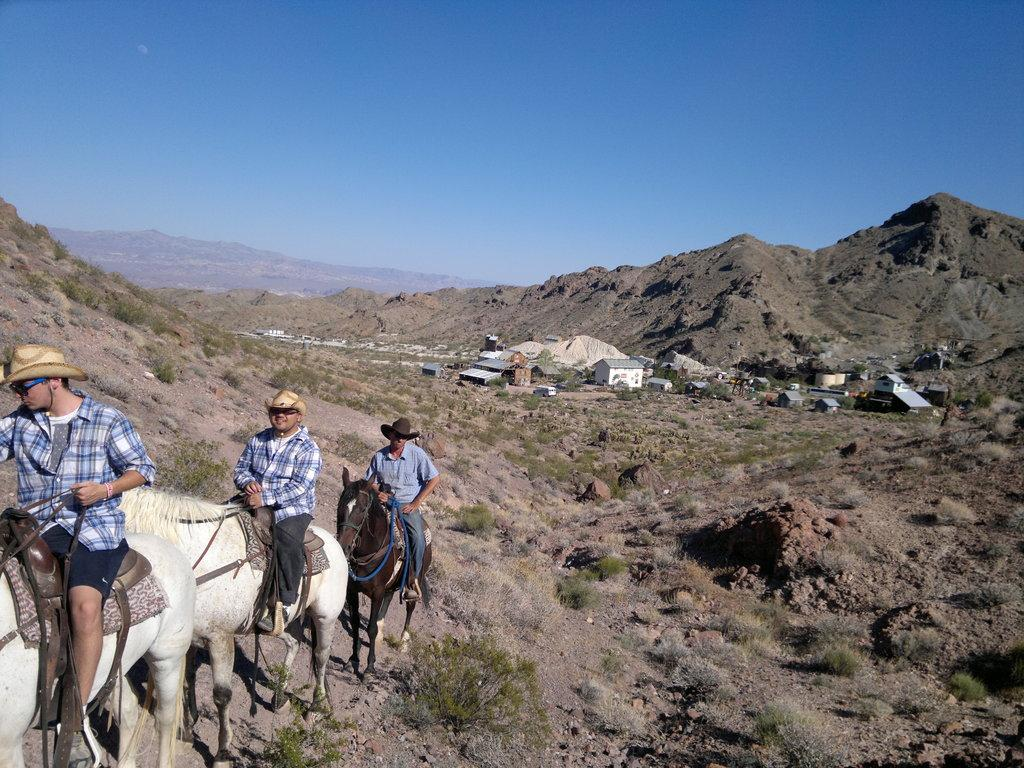What type of structures can be seen in the image? There are shelters in the image. What type of terrain is visible in the image? There is grass, rocks, and hills in the image. What animals are present in the image? There are horses in the image. What are the people in the image doing? People are sitting on horses and wearing hats. What is the color of the sky in the image? The sky is blue in the image. Can you tell me how many apples are being pointed at in the image? There are no apples present in the image, and no one is pointing at anything. Is there an ear visible on any of the horses in the image? There is no ear visible on any of the horses in the image; the focus is on the people sitting on them and their hats. 